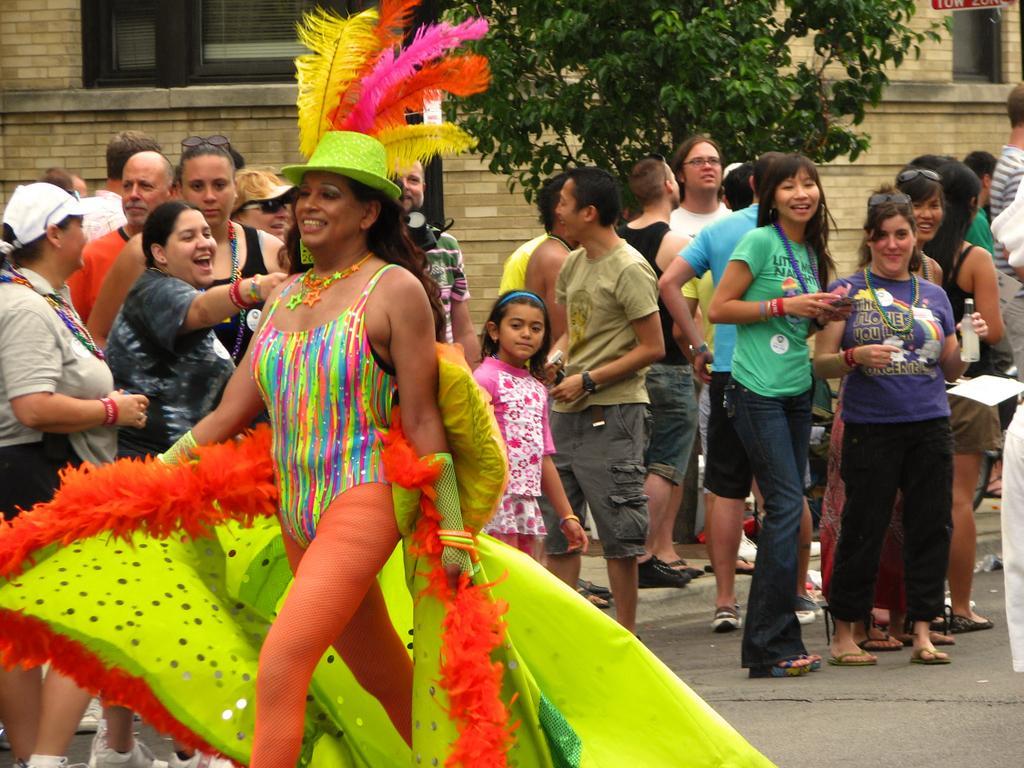Describe this image in one or two sentences. In this image I can see the group of people are standing and wearing different color dresses and few people are holding something. I can see the tree, building and few windows. 